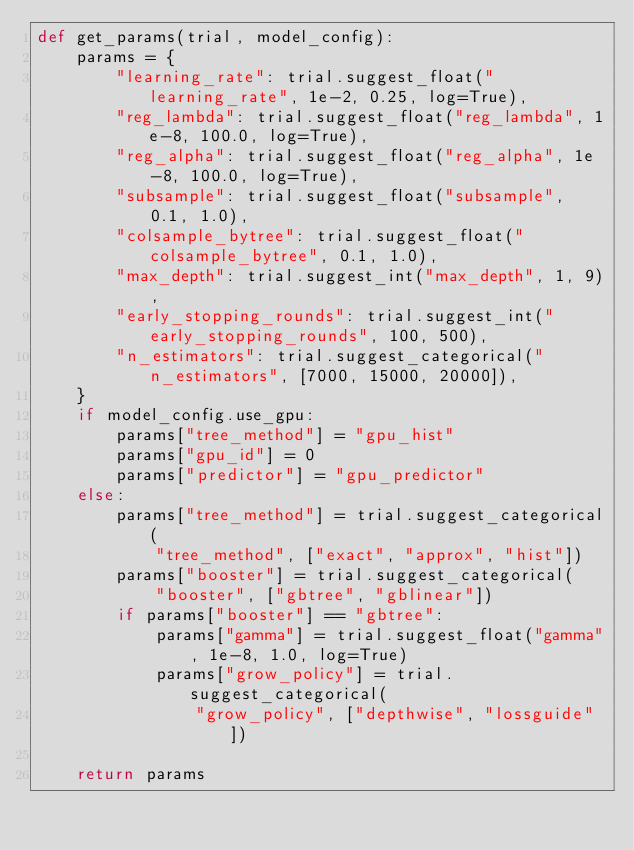<code> <loc_0><loc_0><loc_500><loc_500><_Python_>def get_params(trial, model_config):
    params = {
        "learning_rate": trial.suggest_float("learning_rate", 1e-2, 0.25, log=True),
        "reg_lambda": trial.suggest_float("reg_lambda", 1e-8, 100.0, log=True),
        "reg_alpha": trial.suggest_float("reg_alpha", 1e-8, 100.0, log=True),
        "subsample": trial.suggest_float("subsample", 0.1, 1.0),
        "colsample_bytree": trial.suggest_float("colsample_bytree", 0.1, 1.0),
        "max_depth": trial.suggest_int("max_depth", 1, 9),
        "early_stopping_rounds": trial.suggest_int("early_stopping_rounds", 100, 500),
        "n_estimators": trial.suggest_categorical("n_estimators", [7000, 15000, 20000]),
    }
    if model_config.use_gpu:
        params["tree_method"] = "gpu_hist"
        params["gpu_id"] = 0
        params["predictor"] = "gpu_predictor"
    else:
        params["tree_method"] = trial.suggest_categorical(
            "tree_method", ["exact", "approx", "hist"])
        params["booster"] = trial.suggest_categorical(
            "booster", ["gbtree", "gblinear"])
        if params["booster"] == "gbtree":
            params["gamma"] = trial.suggest_float("gamma", 1e-8, 1.0, log=True)
            params["grow_policy"] = trial.suggest_categorical(
                "grow_policy", ["depthwise", "lossguide"])

    return params
</code> 